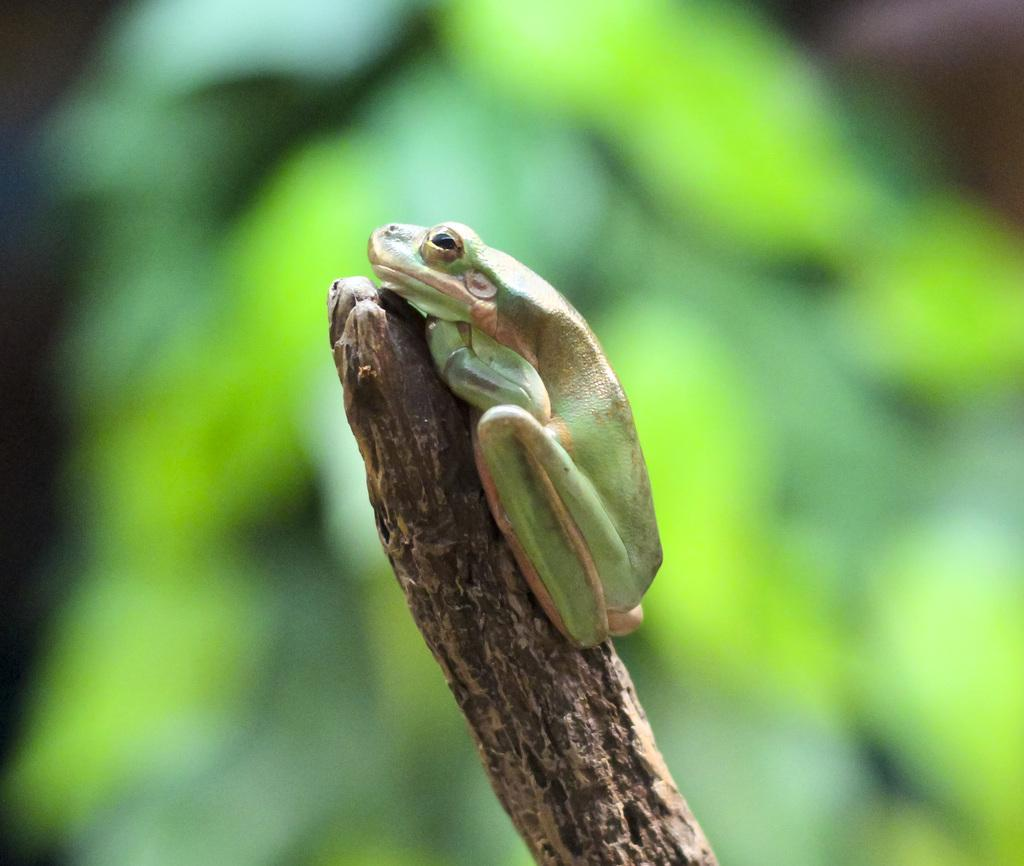What animal is present in the image? There is a frog in the image. What colors can be seen on the frog? The frog is green and brown in color. What is the frog sitting on in the image? The frog is on a wooden stick. How would you describe the background of the image? The background of the image is blurred. How many dimes can be seen on the frog's back in the image? There are no dimes present on the frog's back in the image. What type of crayon is the frog holding in the image? The frog is not holding a crayon in the image. 